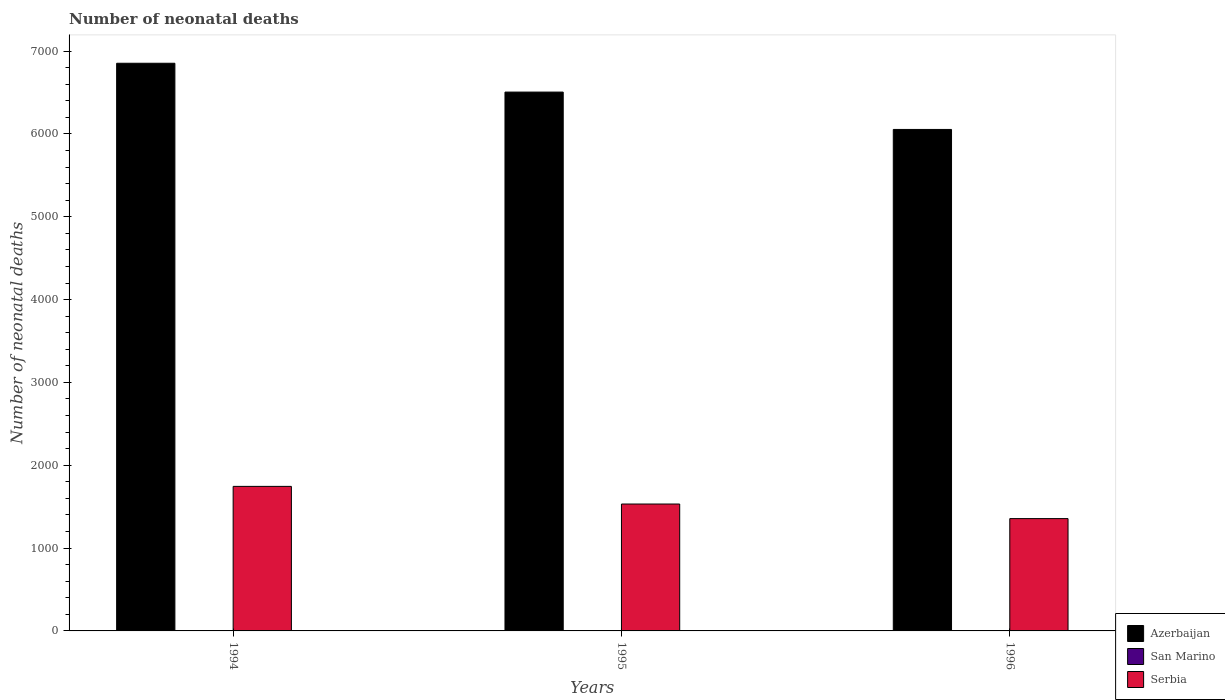Are the number of bars on each tick of the X-axis equal?
Your response must be concise. Yes. How many bars are there on the 2nd tick from the right?
Provide a succinct answer. 3. What is the number of neonatal deaths in in San Marino in 1994?
Your response must be concise. 1. Across all years, what is the maximum number of neonatal deaths in in Serbia?
Ensure brevity in your answer.  1745. Across all years, what is the minimum number of neonatal deaths in in San Marino?
Provide a succinct answer. 1. In which year was the number of neonatal deaths in in San Marino minimum?
Provide a succinct answer. 1994. What is the total number of neonatal deaths in in Azerbaijan in the graph?
Keep it short and to the point. 1.94e+04. What is the difference between the number of neonatal deaths in in Serbia in 1994 and that in 1996?
Give a very brief answer. 389. What is the difference between the number of neonatal deaths in in Azerbaijan in 1996 and the number of neonatal deaths in in San Marino in 1995?
Make the answer very short. 6053. What is the average number of neonatal deaths in in Serbia per year?
Your response must be concise. 1544.33. In the year 1995, what is the difference between the number of neonatal deaths in in Azerbaijan and number of neonatal deaths in in Serbia?
Your answer should be compact. 4973. In how many years, is the number of neonatal deaths in in San Marino greater than 1600?
Offer a terse response. 0. What is the ratio of the number of neonatal deaths in in San Marino in 1994 to that in 1995?
Your answer should be very brief. 1. What is the difference between the highest and the second highest number of neonatal deaths in in Azerbaijan?
Give a very brief answer. 348. What is the difference between the highest and the lowest number of neonatal deaths in in Azerbaijan?
Give a very brief answer. 799. In how many years, is the number of neonatal deaths in in San Marino greater than the average number of neonatal deaths in in San Marino taken over all years?
Offer a very short reply. 0. What does the 2nd bar from the left in 1994 represents?
Provide a succinct answer. San Marino. What does the 1st bar from the right in 1995 represents?
Offer a terse response. Serbia. How many bars are there?
Your answer should be very brief. 9. Are all the bars in the graph horizontal?
Your response must be concise. No. How many years are there in the graph?
Offer a terse response. 3. Are the values on the major ticks of Y-axis written in scientific E-notation?
Offer a very short reply. No. Does the graph contain any zero values?
Provide a short and direct response. No. Does the graph contain grids?
Your response must be concise. No. Where does the legend appear in the graph?
Your response must be concise. Bottom right. How are the legend labels stacked?
Ensure brevity in your answer.  Vertical. What is the title of the graph?
Your answer should be very brief. Number of neonatal deaths. What is the label or title of the Y-axis?
Offer a terse response. Number of neonatal deaths. What is the Number of neonatal deaths of Azerbaijan in 1994?
Make the answer very short. 6853. What is the Number of neonatal deaths of Serbia in 1994?
Ensure brevity in your answer.  1745. What is the Number of neonatal deaths of Azerbaijan in 1995?
Provide a succinct answer. 6505. What is the Number of neonatal deaths in Serbia in 1995?
Offer a very short reply. 1532. What is the Number of neonatal deaths in Azerbaijan in 1996?
Provide a succinct answer. 6054. What is the Number of neonatal deaths of Serbia in 1996?
Your response must be concise. 1356. Across all years, what is the maximum Number of neonatal deaths in Azerbaijan?
Your answer should be compact. 6853. Across all years, what is the maximum Number of neonatal deaths of San Marino?
Ensure brevity in your answer.  1. Across all years, what is the maximum Number of neonatal deaths of Serbia?
Keep it short and to the point. 1745. Across all years, what is the minimum Number of neonatal deaths of Azerbaijan?
Give a very brief answer. 6054. Across all years, what is the minimum Number of neonatal deaths in Serbia?
Ensure brevity in your answer.  1356. What is the total Number of neonatal deaths of Azerbaijan in the graph?
Give a very brief answer. 1.94e+04. What is the total Number of neonatal deaths of Serbia in the graph?
Your answer should be very brief. 4633. What is the difference between the Number of neonatal deaths in Azerbaijan in 1994 and that in 1995?
Your answer should be very brief. 348. What is the difference between the Number of neonatal deaths of Serbia in 1994 and that in 1995?
Offer a very short reply. 213. What is the difference between the Number of neonatal deaths of Azerbaijan in 1994 and that in 1996?
Ensure brevity in your answer.  799. What is the difference between the Number of neonatal deaths of Serbia in 1994 and that in 1996?
Give a very brief answer. 389. What is the difference between the Number of neonatal deaths of Azerbaijan in 1995 and that in 1996?
Offer a very short reply. 451. What is the difference between the Number of neonatal deaths in San Marino in 1995 and that in 1996?
Make the answer very short. 0. What is the difference between the Number of neonatal deaths of Serbia in 1995 and that in 1996?
Your response must be concise. 176. What is the difference between the Number of neonatal deaths of Azerbaijan in 1994 and the Number of neonatal deaths of San Marino in 1995?
Give a very brief answer. 6852. What is the difference between the Number of neonatal deaths of Azerbaijan in 1994 and the Number of neonatal deaths of Serbia in 1995?
Keep it short and to the point. 5321. What is the difference between the Number of neonatal deaths in San Marino in 1994 and the Number of neonatal deaths in Serbia in 1995?
Ensure brevity in your answer.  -1531. What is the difference between the Number of neonatal deaths in Azerbaijan in 1994 and the Number of neonatal deaths in San Marino in 1996?
Provide a short and direct response. 6852. What is the difference between the Number of neonatal deaths of Azerbaijan in 1994 and the Number of neonatal deaths of Serbia in 1996?
Keep it short and to the point. 5497. What is the difference between the Number of neonatal deaths of San Marino in 1994 and the Number of neonatal deaths of Serbia in 1996?
Ensure brevity in your answer.  -1355. What is the difference between the Number of neonatal deaths in Azerbaijan in 1995 and the Number of neonatal deaths in San Marino in 1996?
Your answer should be very brief. 6504. What is the difference between the Number of neonatal deaths of Azerbaijan in 1995 and the Number of neonatal deaths of Serbia in 1996?
Ensure brevity in your answer.  5149. What is the difference between the Number of neonatal deaths in San Marino in 1995 and the Number of neonatal deaths in Serbia in 1996?
Make the answer very short. -1355. What is the average Number of neonatal deaths of Azerbaijan per year?
Offer a very short reply. 6470.67. What is the average Number of neonatal deaths of San Marino per year?
Offer a terse response. 1. What is the average Number of neonatal deaths of Serbia per year?
Ensure brevity in your answer.  1544.33. In the year 1994, what is the difference between the Number of neonatal deaths in Azerbaijan and Number of neonatal deaths in San Marino?
Provide a short and direct response. 6852. In the year 1994, what is the difference between the Number of neonatal deaths in Azerbaijan and Number of neonatal deaths in Serbia?
Your response must be concise. 5108. In the year 1994, what is the difference between the Number of neonatal deaths of San Marino and Number of neonatal deaths of Serbia?
Give a very brief answer. -1744. In the year 1995, what is the difference between the Number of neonatal deaths of Azerbaijan and Number of neonatal deaths of San Marino?
Keep it short and to the point. 6504. In the year 1995, what is the difference between the Number of neonatal deaths in Azerbaijan and Number of neonatal deaths in Serbia?
Give a very brief answer. 4973. In the year 1995, what is the difference between the Number of neonatal deaths in San Marino and Number of neonatal deaths in Serbia?
Your answer should be very brief. -1531. In the year 1996, what is the difference between the Number of neonatal deaths of Azerbaijan and Number of neonatal deaths of San Marino?
Ensure brevity in your answer.  6053. In the year 1996, what is the difference between the Number of neonatal deaths in Azerbaijan and Number of neonatal deaths in Serbia?
Give a very brief answer. 4698. In the year 1996, what is the difference between the Number of neonatal deaths in San Marino and Number of neonatal deaths in Serbia?
Your answer should be very brief. -1355. What is the ratio of the Number of neonatal deaths of Azerbaijan in 1994 to that in 1995?
Your response must be concise. 1.05. What is the ratio of the Number of neonatal deaths in Serbia in 1994 to that in 1995?
Give a very brief answer. 1.14. What is the ratio of the Number of neonatal deaths in Azerbaijan in 1994 to that in 1996?
Keep it short and to the point. 1.13. What is the ratio of the Number of neonatal deaths of Serbia in 1994 to that in 1996?
Make the answer very short. 1.29. What is the ratio of the Number of neonatal deaths in Azerbaijan in 1995 to that in 1996?
Make the answer very short. 1.07. What is the ratio of the Number of neonatal deaths in Serbia in 1995 to that in 1996?
Ensure brevity in your answer.  1.13. What is the difference between the highest and the second highest Number of neonatal deaths of Azerbaijan?
Offer a very short reply. 348. What is the difference between the highest and the second highest Number of neonatal deaths of Serbia?
Offer a very short reply. 213. What is the difference between the highest and the lowest Number of neonatal deaths in Azerbaijan?
Provide a short and direct response. 799. What is the difference between the highest and the lowest Number of neonatal deaths of Serbia?
Your answer should be compact. 389. 